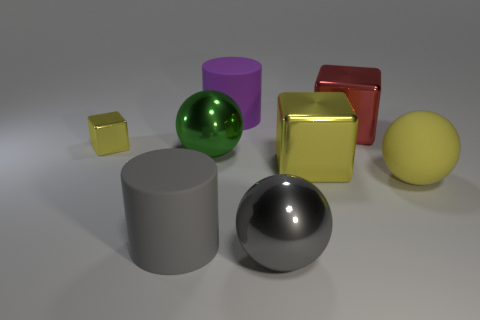What is the shape of the rubber thing that is on the left side of the big gray metallic thing and right of the big green metallic sphere?
Your response must be concise. Cylinder. What number of big gray cylinders are made of the same material as the green object?
Make the answer very short. 0. What number of gray things are to the left of the matte cylinder behind the large rubber ball?
Give a very brief answer. 1. There is a large gray thing in front of the big cylinder on the left side of the green shiny object that is behind the big gray matte cylinder; what shape is it?
Your answer should be compact. Sphere. How many objects are blocks or small yellow objects?
Your answer should be compact. 3. What color is the other metal block that is the same size as the red block?
Your response must be concise. Yellow. There is a gray matte object; is it the same shape as the large gray object to the right of the big green sphere?
Offer a terse response. No. What number of objects are either large red metallic objects that are to the left of the big yellow sphere or large spheres in front of the big green ball?
Offer a terse response. 3. There is a rubber object that is the same color as the small metallic cube; what shape is it?
Ensure brevity in your answer.  Sphere. There is a large metal object in front of the large yellow metallic cube; what shape is it?
Your answer should be very brief. Sphere. 